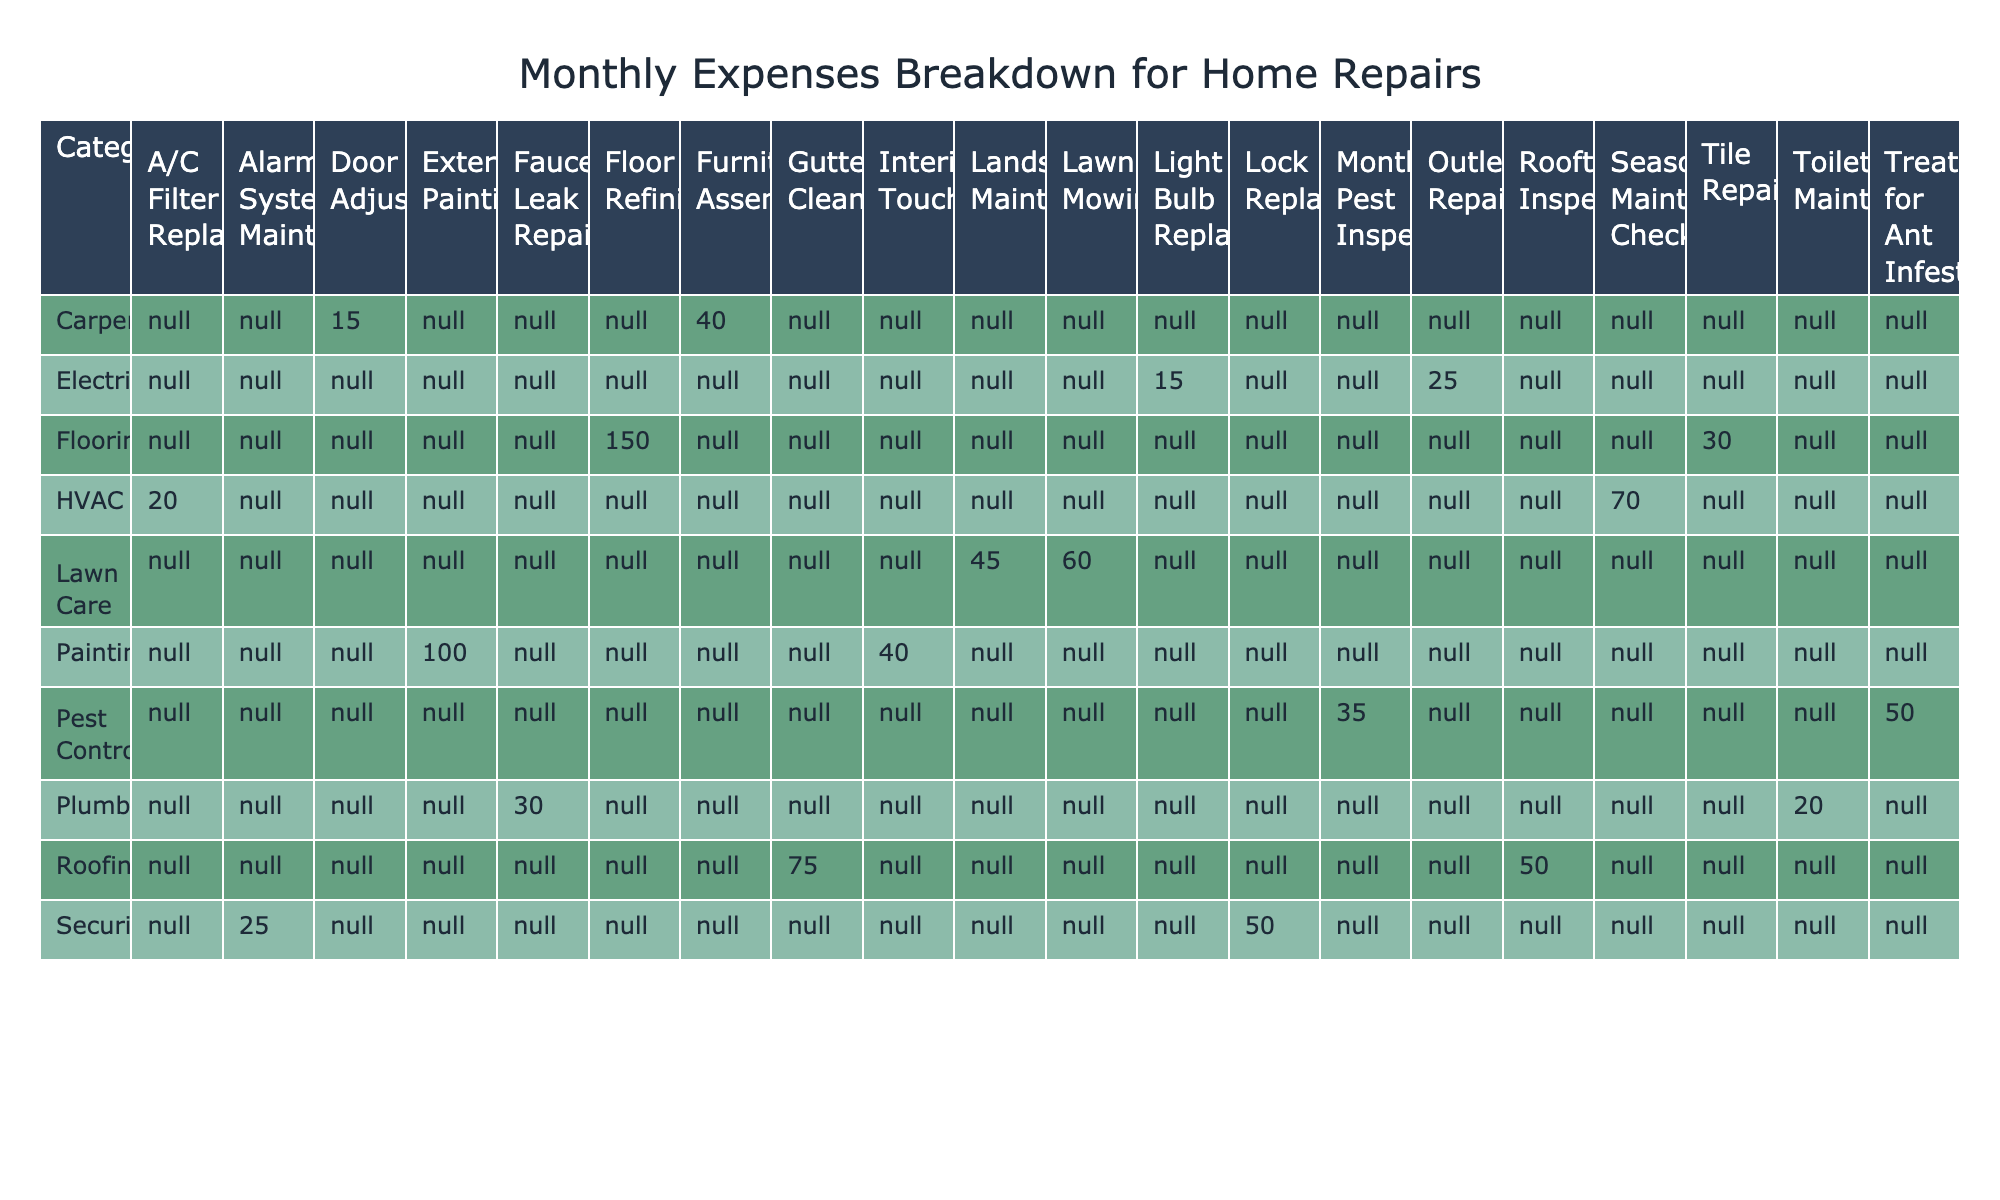What's the total monthly expense for Pest Control? The monthly expenses for Pest Control are 35 for Monthly Pest Inspection and 50 for Treatment for Ant Infestation. Adding these amounts together: 35 + 50 = 85.
Answer: 85 What is the most expensive item in the table? By examining the expenses for each item, Exterior Painting has the highest cost at 100.
Answer: 100 How much do I spend on Carpentry in total? The expenses for Carpentry are 15 for Door Adjustment and 40 for Furniture Assembly. Adding these gives: 15 + 40 = 55.
Answer: 55 Is the expense for Lawn Mowing higher than that for Outlet Repair? The expense for Lawn Mowing is 60, and for Outlet Repair it is 25. Since 60 is greater than 25, the statement is true.
Answer: Yes What is the average monthly expense for the Roofing category? The expenses for Roofing are 50 for Rooftop Inspection and 75 for Gutter Cleaning. The total is 50 + 75 = 125. There are 2 items, so the average is 125 / 2 = 62.5.
Answer: 62.5 Which category has the lowest total expense? Summing up the expenses in each category, Electrical totals 40, Plumbing totals 50, and all others are higher. Therefore, Electrical has the lowest total expense.
Answer: Electrical How much more does it cost to replace a lock compared to adjusting a door? The cost to replace a lock is 50, and the cost for door adjustment is 15. The difference is 50 - 15 = 35.
Answer: 35 What is the total expense for all HVAC-related repairs? The HVAC expenses are 20 for A/C Filter Replacement and 70 for Seasonal Maintenance Check. Adding these gives: 20 + 70 = 90.
Answer: 90 If I wanted to combine the expenses for both types of Painting, how much would that be? The expenses are 40 for Interior Touch-Ups and 100 for Exterior Painting. Adding these gives: 40 + 100 = 140.
Answer: 140 Is the sum of the expenses for Electrical repairs greater than the sum for Flooring repairs? The total for Electrical is 40 (15 + 25), and for Flooring is 180 (30 + 150). Since 40 is less than 180, the statement is false.
Answer: No 